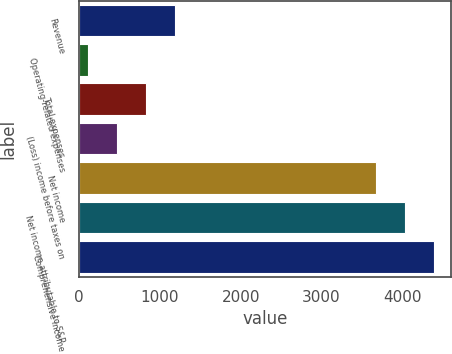<chart> <loc_0><loc_0><loc_500><loc_500><bar_chart><fcel>Revenue<fcel>Operating-related expenses<fcel>Total expenses<fcel>(Loss) income before taxes on<fcel>Net income<fcel>Net income attributable to S&P<fcel>Comprehensive income<nl><fcel>1183.8<fcel>108<fcel>825.2<fcel>466.6<fcel>3670<fcel>4028.6<fcel>4387.2<nl></chart> 